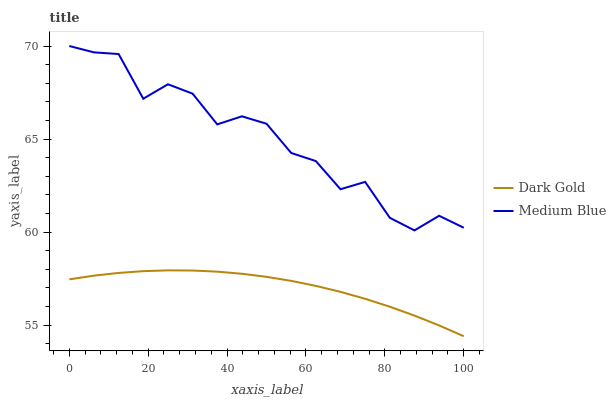Does Dark Gold have the maximum area under the curve?
Answer yes or no. No. Is Dark Gold the roughest?
Answer yes or no. No. Does Dark Gold have the highest value?
Answer yes or no. No. Is Dark Gold less than Medium Blue?
Answer yes or no. Yes. Is Medium Blue greater than Dark Gold?
Answer yes or no. Yes. Does Dark Gold intersect Medium Blue?
Answer yes or no. No. 